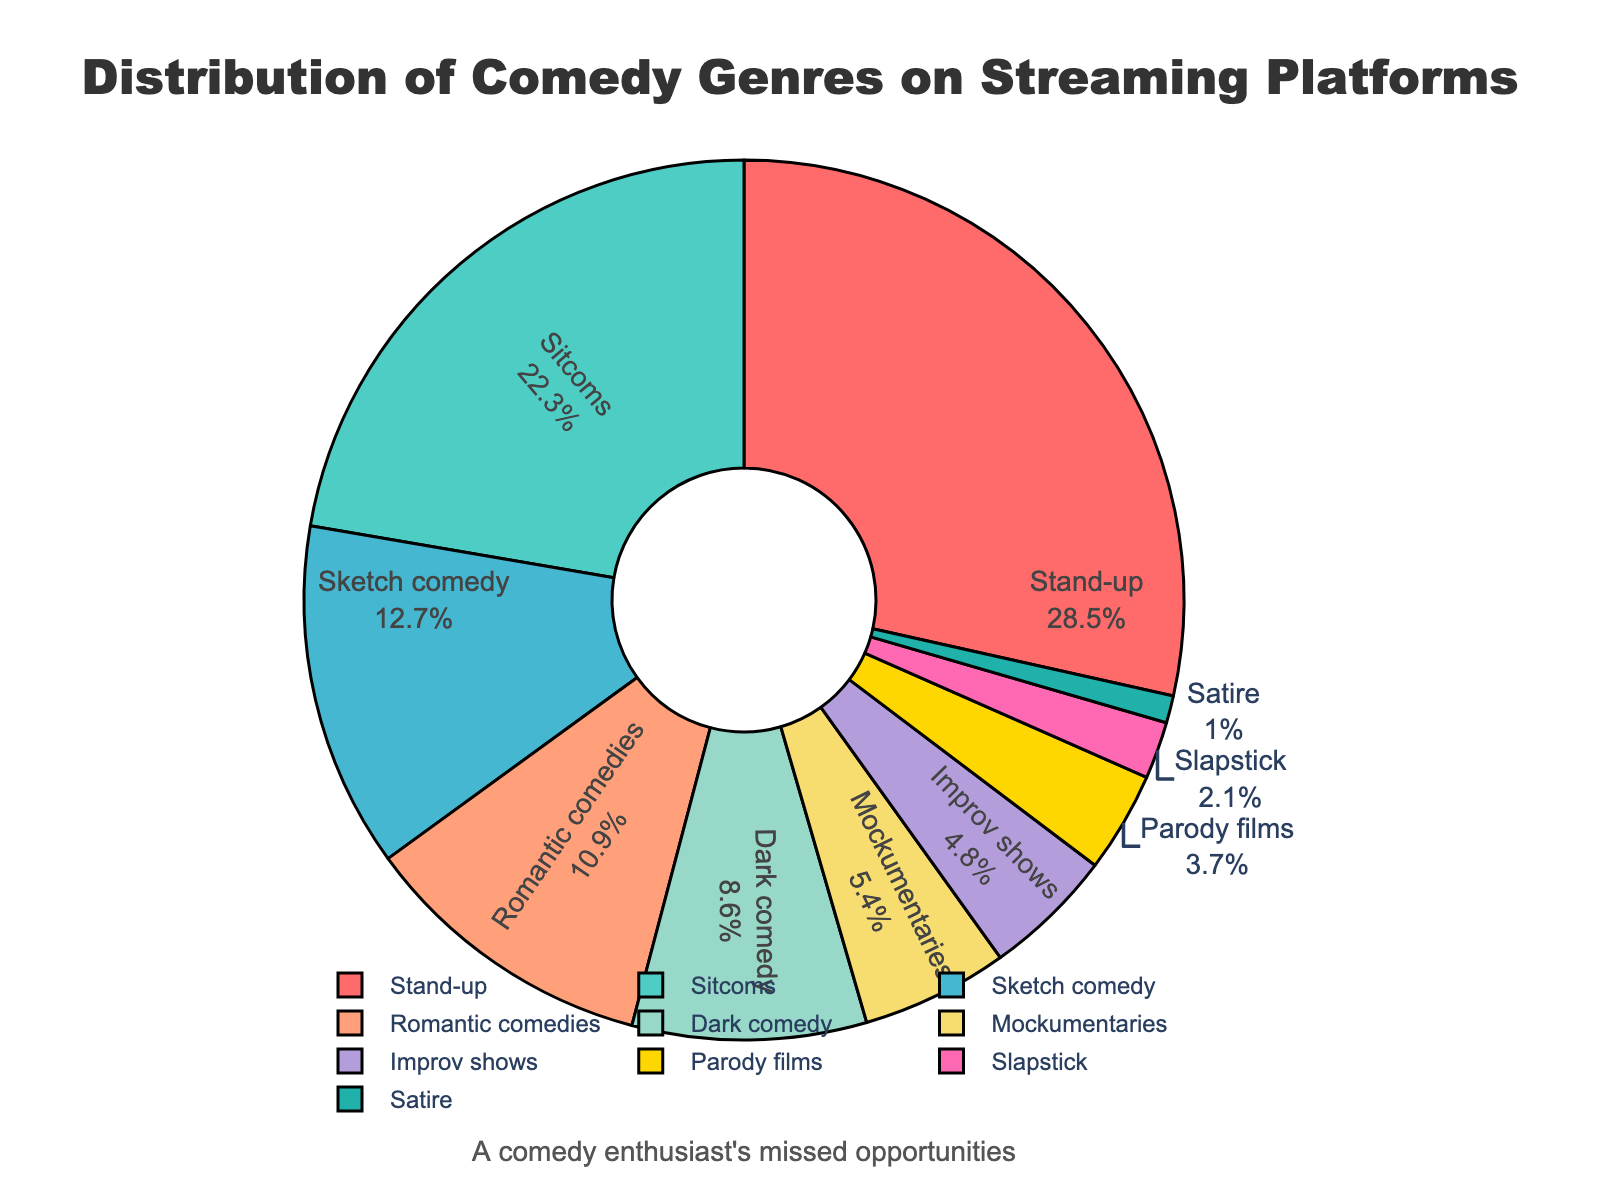What comedy genre makes up the largest percentage on streaming platforms? The pie chart shows that the segment representing Stand-up is the largest, with a percentage of 28.5%.
Answer: Stand-up What is the combined percentage of Sitcoms and Sketch comedy? Sitcoms has a percentage of 22.3% and Sketch comedy has 12.7%. Adding these together, 22.3% + 12.7% = 35.0%.
Answer: 35.0% How does Romantic comedies compare to Dark comedy in terms of percentage? Romantic comedies have a percentage of 10.9%, while Dark comedy has 8.6%. Romantic comedies have a higher percentage by 10.9% - 8.6% = 2.3%.
Answer: Romantic comedies are 2.3% higher Which genre makes up the smallest percentage of comedy on streaming platforms? The pie chart shows that Satire is the smallest segment, with a percentage of 1.0%.
Answer: Satire What is the combined percentage of the three least common comedy genres? The percentages for the three least common genres are Satire (1.0%), Slapstick (2.1%), and Parody films (3.7%). Adding these together, 1.0% + 2.1% + 3.7% = 6.8%.
Answer: 6.8% By how much does the percentage of Improv shows exceed that of Satire? The percentage of Improv shows is 4.8%, and Satire is 1.0%. The difference is 4.8% - 1.0% = 3.8%.
Answer: 3.8% Identify the comedy genres that collectively make up more than 50% of the chart. Stand-up (28.5%), Sitcoms (22.3%), Sketch comedy (12.7%), and Romantic comedies (10.9%) together compose more than half of the chart: 28.5% + 22.3% + 12.7% + 10.9% = 74.4%.
Answer: Stand-up, Sitcoms, Sketch comedy, Romantic comedies What color represents Romantic comedies on the pie chart? The color representing Romantic comedies on the pie chart is peach or light orange.
Answer: Peach (light orange) What is the percentage difference between the most and least common comedy genres? The most common genre is Stand-up with 28.5%, and the least common is Satire with 1.0%. The difference is 28.5% - 1.0% = 27.5%.
Answer: 27.5% Which genre has a percentage closest to 5%, and what is it? The genre closest to 5% is Mockumentaries, with a percentage of 5.4%.
Answer: Mockumentaries, 5.4% 